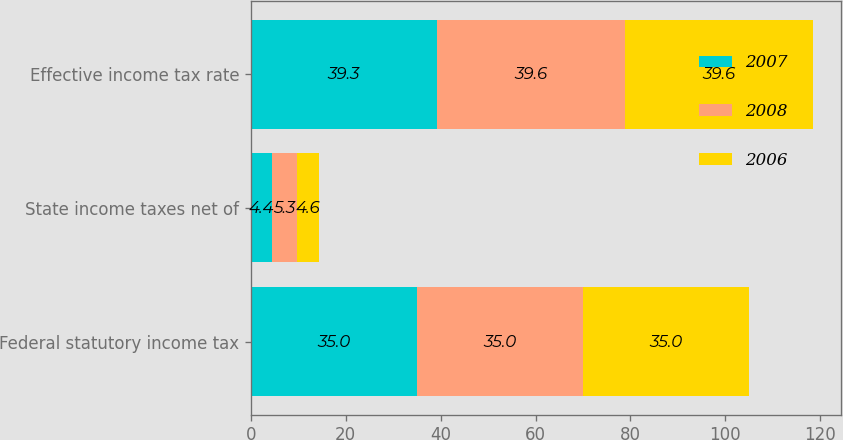Convert chart to OTSL. <chart><loc_0><loc_0><loc_500><loc_500><stacked_bar_chart><ecel><fcel>Federal statutory income tax<fcel>State income taxes net of<fcel>Effective income tax rate<nl><fcel>2007<fcel>35<fcel>4.4<fcel>39.3<nl><fcel>2008<fcel>35<fcel>5.3<fcel>39.6<nl><fcel>2006<fcel>35<fcel>4.6<fcel>39.6<nl></chart> 